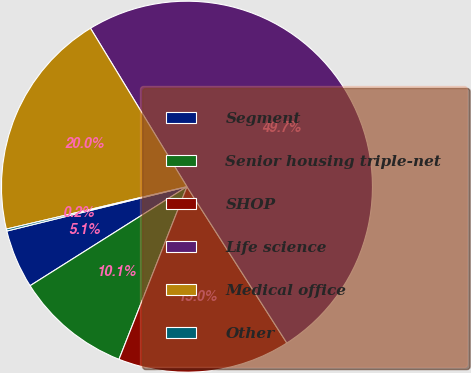<chart> <loc_0><loc_0><loc_500><loc_500><pie_chart><fcel>Segment<fcel>Senior housing triple-net<fcel>SHOP<fcel>Life science<fcel>Medical office<fcel>Other<nl><fcel>5.12%<fcel>10.07%<fcel>15.02%<fcel>49.66%<fcel>19.97%<fcel>0.17%<nl></chart> 